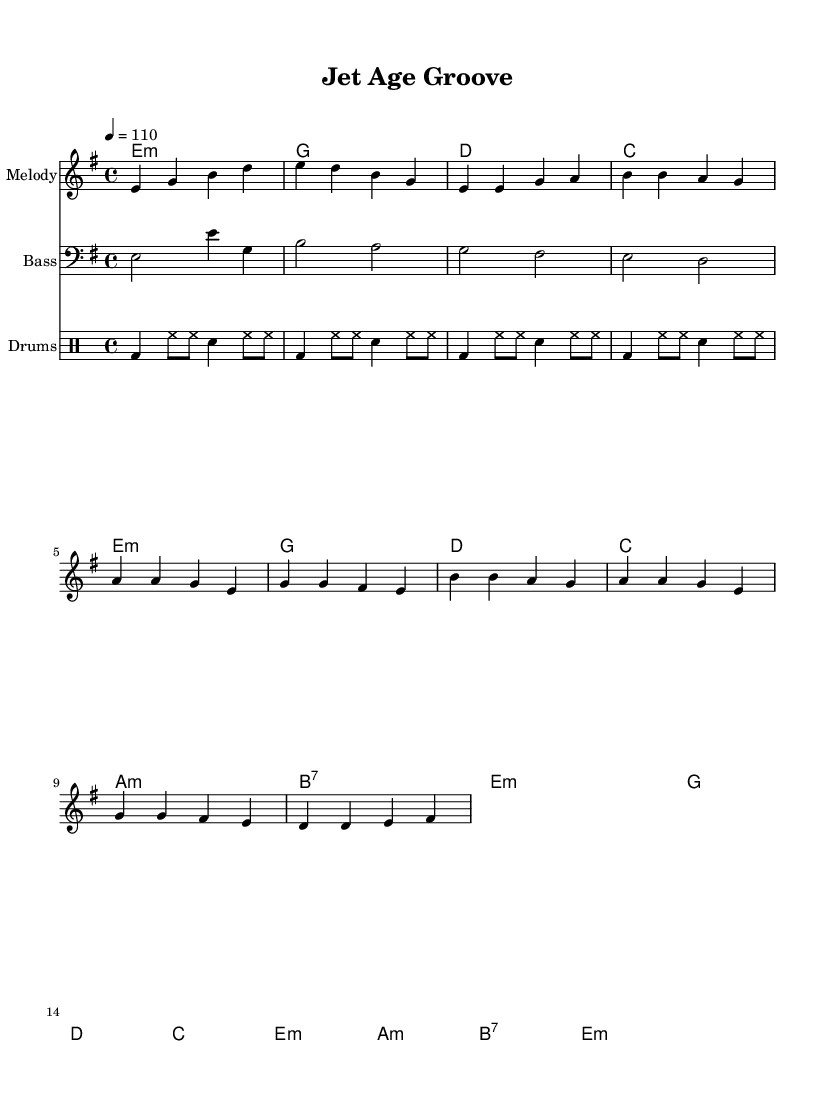What is the key signature of this music? The key signature is E minor, which has one sharp (F#) and typically relates to its relative major, G major. This is indicated at the beginning of the sheet music by the note indicating the key.
Answer: E minor What is the time signature of this music? The time signature is 4/4, which means there are four beats in each measure and a quarter note receives one beat. This is noted at the beginning of the staff in the upper part of the sheet music.
Answer: 4/4 What is the tempo marking of this piece? The piece is marked with a tempo of 110 beats per minute, indicated by the term "4 = 110" at the beginning of the score, which specifies the speed of the music.
Answer: 110 What chord follows the 'Intro' section harmonically? The chord progression starts with E minor in the Intro, as specified in the harmonies section. The chord immediately following E minor in the harmonic structure is G major.
Answer: G How many measures are in the 'Chorus' section? By looking at the score, the 'Chorus' is made up of four measures directly following the 'Verse.' Each measure can be counted individually to arrive at the total.
Answer: 4 Identify the primary role of the bass in this piece. The bass line provides the foundational pitch framework for the music, reinforcing the chord progressions while creating alternating rhythmic patterns, highlighted in the bass staff section of the score.
Answer: Foundation What unique rhythmic element is commonly found in funk music and reflected in this sheet? The rhythmic aspect of funk is notably characterized by syncopation, which creates a distinctive groove. The drum patterns displayed indicate the use of off-beats and accents typical of funk music.
Answer: Syncopation 